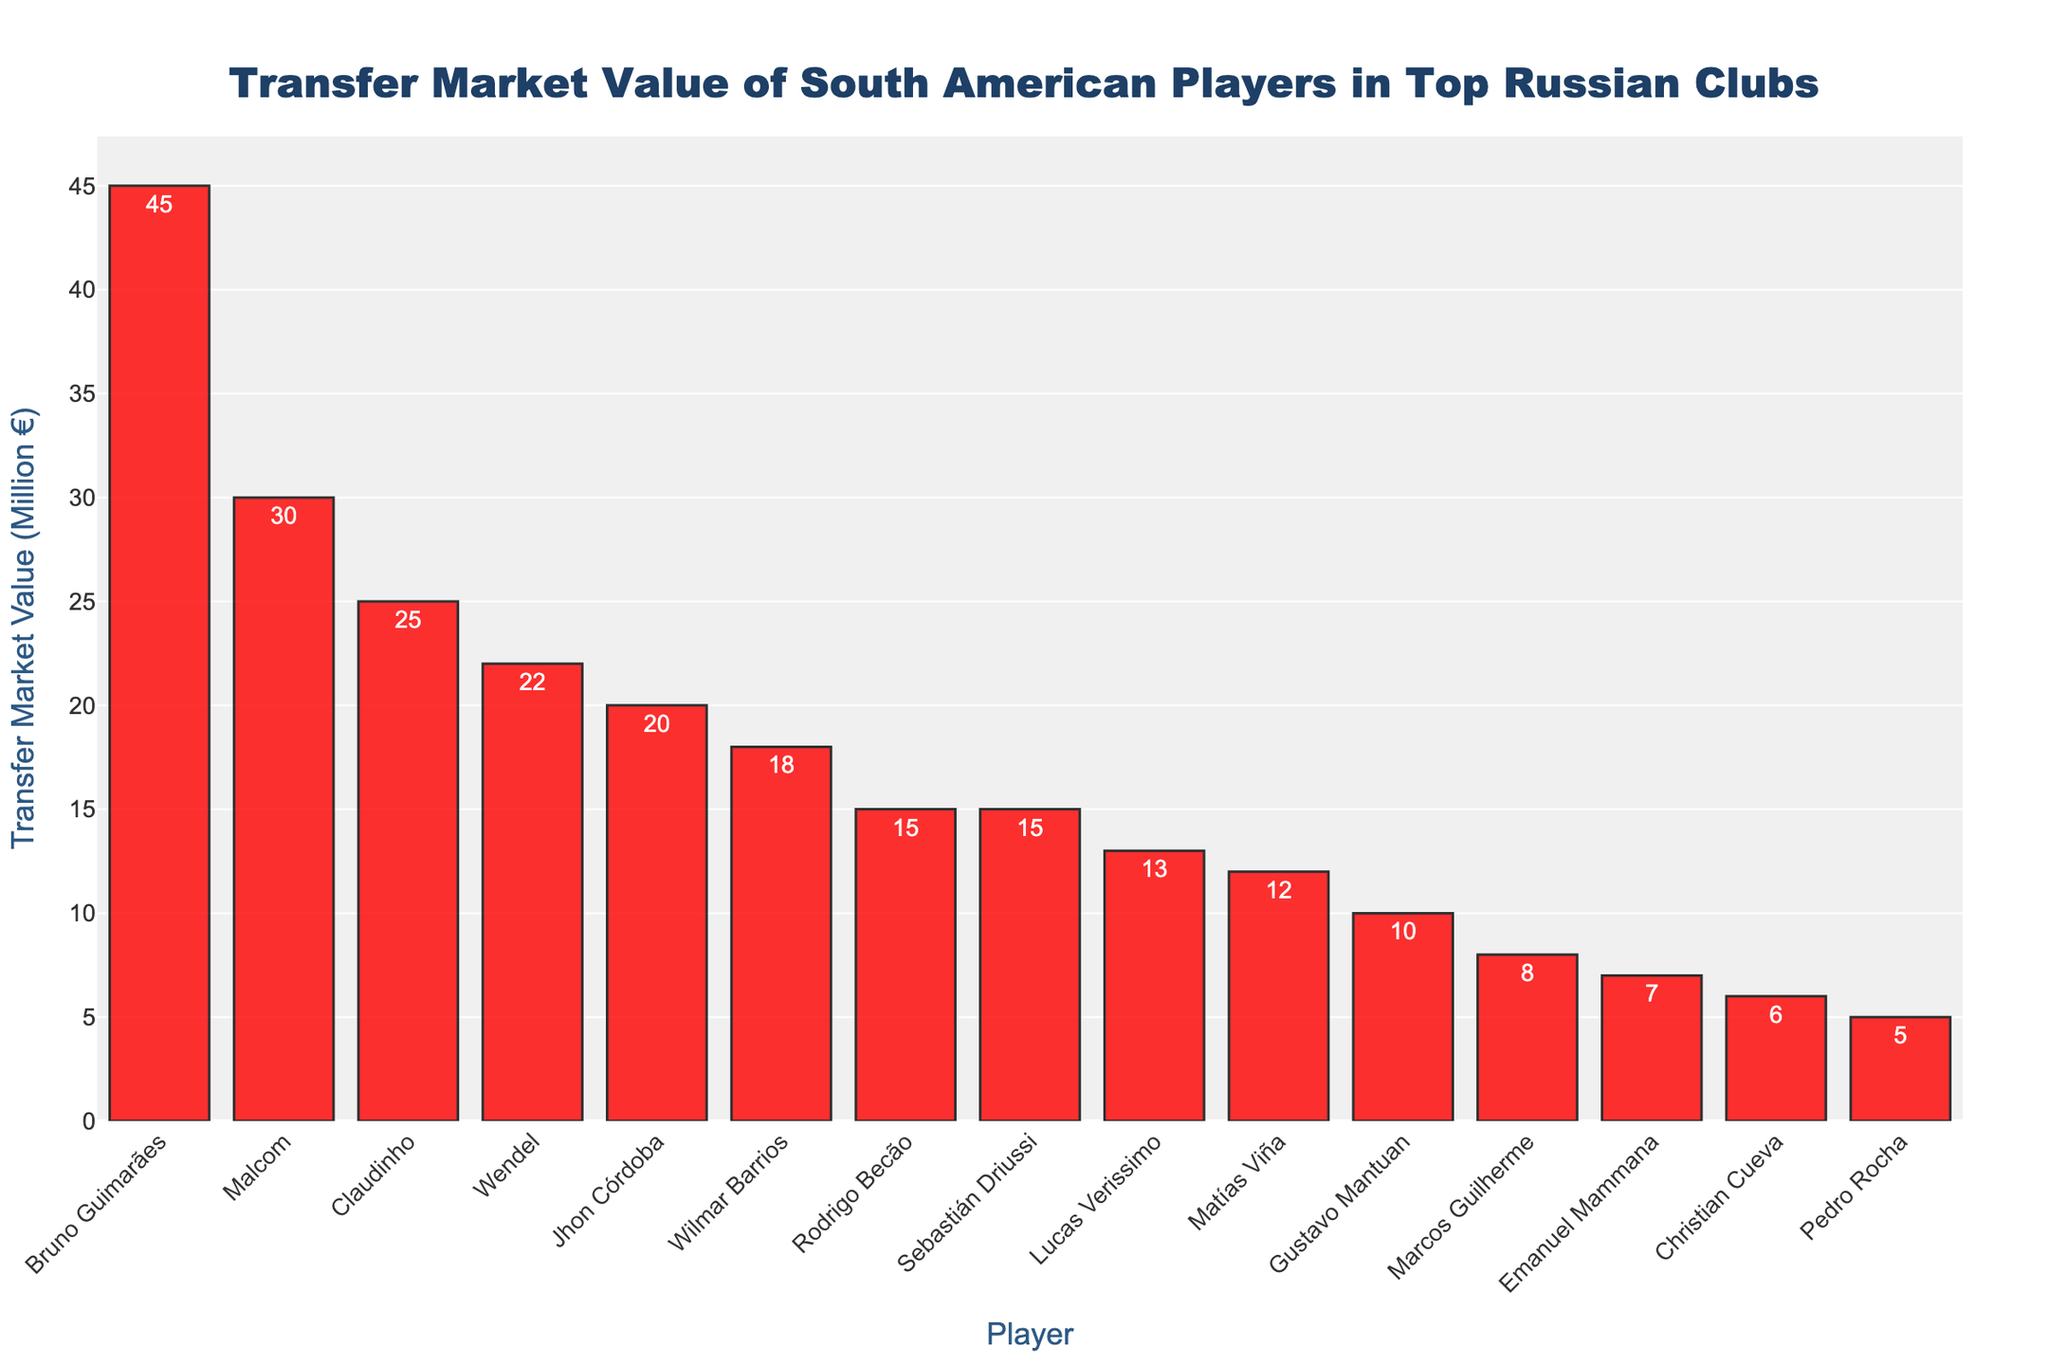Which player has the highest transfer market value? Look at the bar with the greatest height. It corresponds to Bruno Guimarães from Zenit St. Petersburg with a value of €45 million.
Answer: Bruno Guimarães Which club has the most players in the top 5 highest transfer market values? Identify the clubs associated with the top 5 highest-valued players. Zenit St. Petersburg is associated with Bruno Guimarães, Claudinho, Malcom, and Wendel.
Answer: Zenit St. Petersburg What is the total transfer market value of all players from Zenit St. Petersburg? Sum the transfer market values of all listed Zenit St. Petersburg players: 45 + 25 + 22 + 30 + 18 + 10 + 15. This totals €165 million.
Answer: €165 million Who is the least valuable player and which club do they play for? Look for the smallest bar. It corresponds to Pedro Rocha from Spartak Moscow with a value of €5 million.
Answer: Pedro Rocha, Spartak Moscow What is the average transfer market value of players in Spartak Moscow? Sum the values of Spartak Moscow players (12 + 5 + 13) and divide by the number of players (3). The total is 30, so the average is 30/3 = 10.
Answer: €10 million How does the transfer market value of Gustavo Mantuan compare to Emanuel Mammana? Find the heights of the bars for Gustavo Mantuan (€10 million) and Emanuel Mammana (€7 million). Gustavo Mantuan's value is greater.
Answer: Gustavo Mantuan is greater What is the difference in transfer market value between Malcom and Claudinho? Subtract Claudinho's value (€25 million) from Malcom's value (€30 million). The difference is €5 million.
Answer: €5 million Which club has the second most valuable player? The second highest bar after Bruno Guimarães corresponds to Malcom from Zenit St. Petersburg.
Answer: Zenit St. Petersburg What is the range of transfer market values for players in this chart? Subtract the lowest value (€5 million) from the highest value (€45 million). The range is €40 million.
Answer: €40 million If you combined the transfer market values of all players from CSKA Moscow and Lokomotiv Moscow, what would be the total? Add the values of players from CSKA Moscow (15) and Lokomotiv Moscow (8). The total is 15 + 8 = €23 million.
Answer: €23 million 